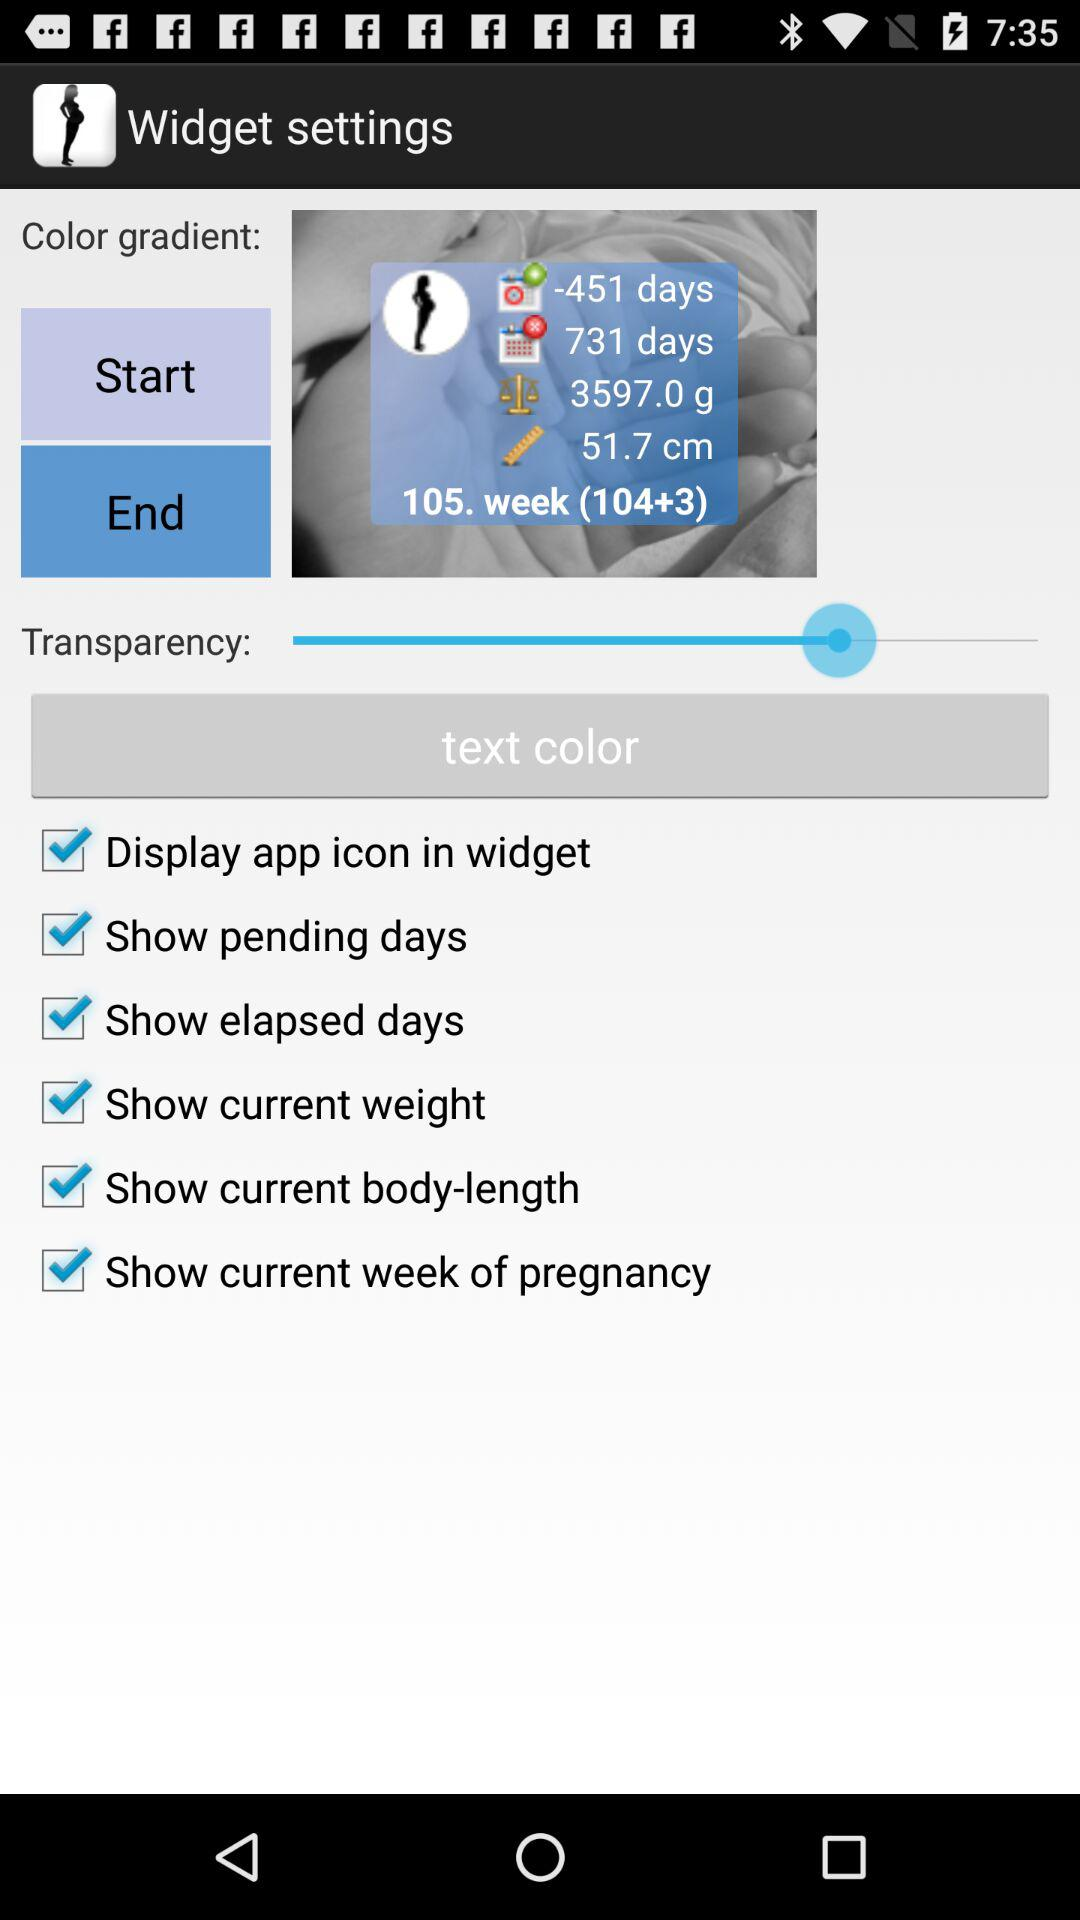What is the current weight of the body?
When the provided information is insufficient, respond with <no answer>. <no answer> 